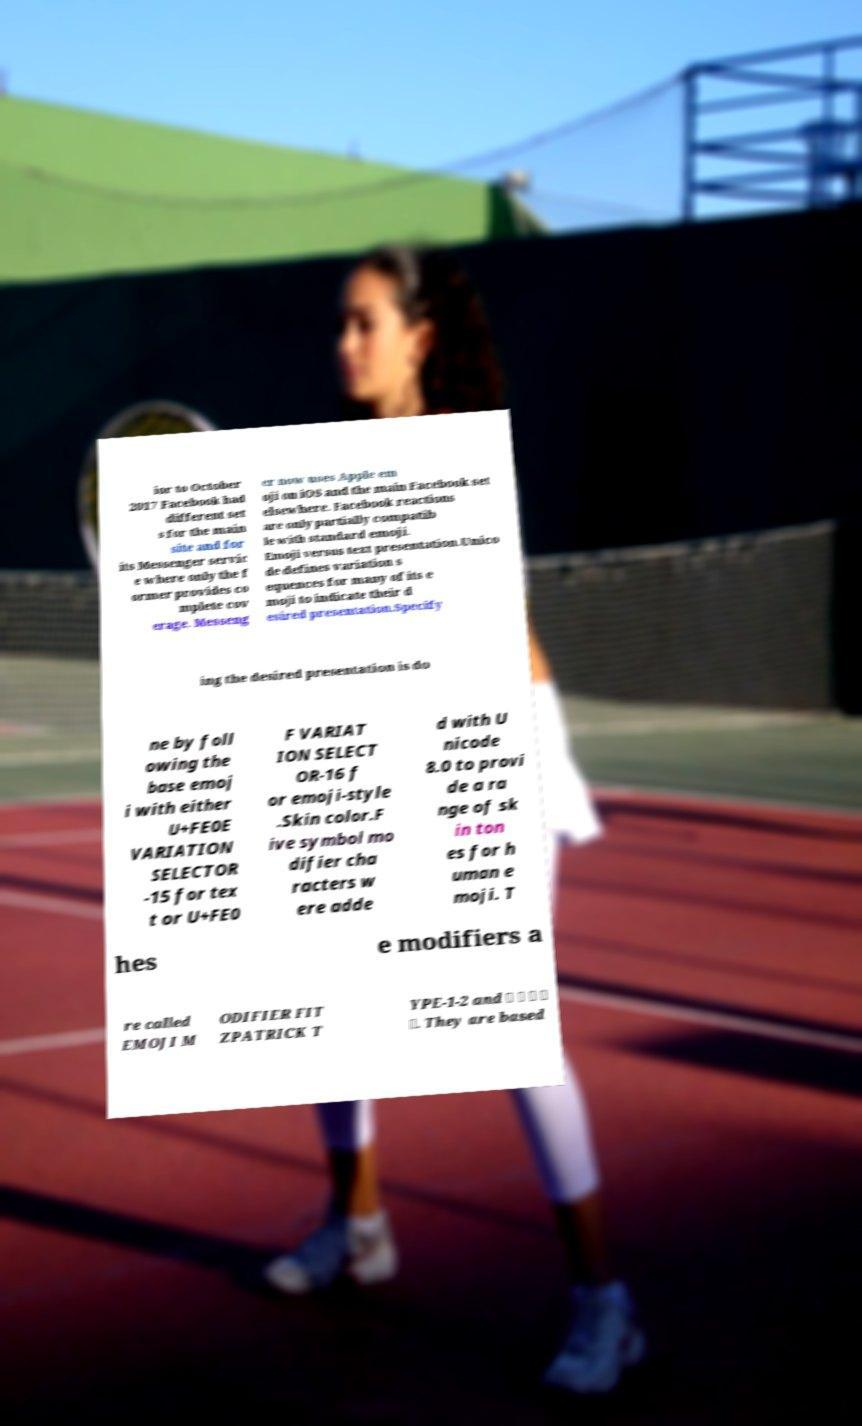Please identify and transcribe the text found in this image. ior to October 2017 Facebook had different set s for the main site and for its Messenger servic e where only the f ormer provides co mplete cov erage. Messeng er now uses Apple em oji on iOS and the main Facebook set elsewhere. Facebook reactions are only partially compatib le with standard emoji. Emoji versus text presentation.Unico de defines variation s equences for many of its e moji to indicate their d esired presentation.Specify ing the desired presentation is do ne by foll owing the base emoj i with either U+FE0E VARIATION SELECTOR -15 for tex t or U+FE0 F VARIAT ION SELECT OR-16 f or emoji-style .Skin color.F ive symbol mo difier cha racters w ere adde d with U nicode 8.0 to provi de a ra nge of sk in ton es for h uman e moji. T hes e modifiers a re called EMOJI M ODIFIER FIT ZPATRICK T YPE-1-2 and 🏻 🏼 🏽 🏾 🏿. They are based 